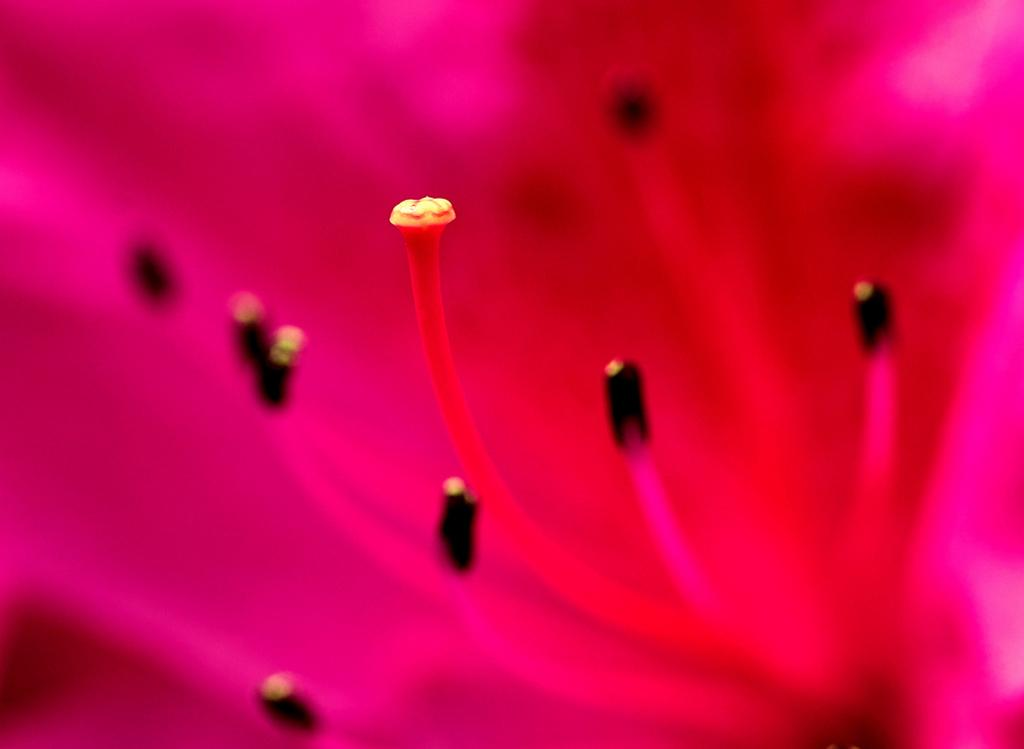What is the main subject of focus of the image? There is a flower in the image. Can you describe the color of the flower? The flower is pink in color. How many feet are visible in the image? There are no feet visible in the image; it only features a pink flower. What type of plot is being developed in the image? There is no plot being developed in the image; the image only contains a pink flower. 